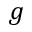<formula> <loc_0><loc_0><loc_500><loc_500>g</formula> 